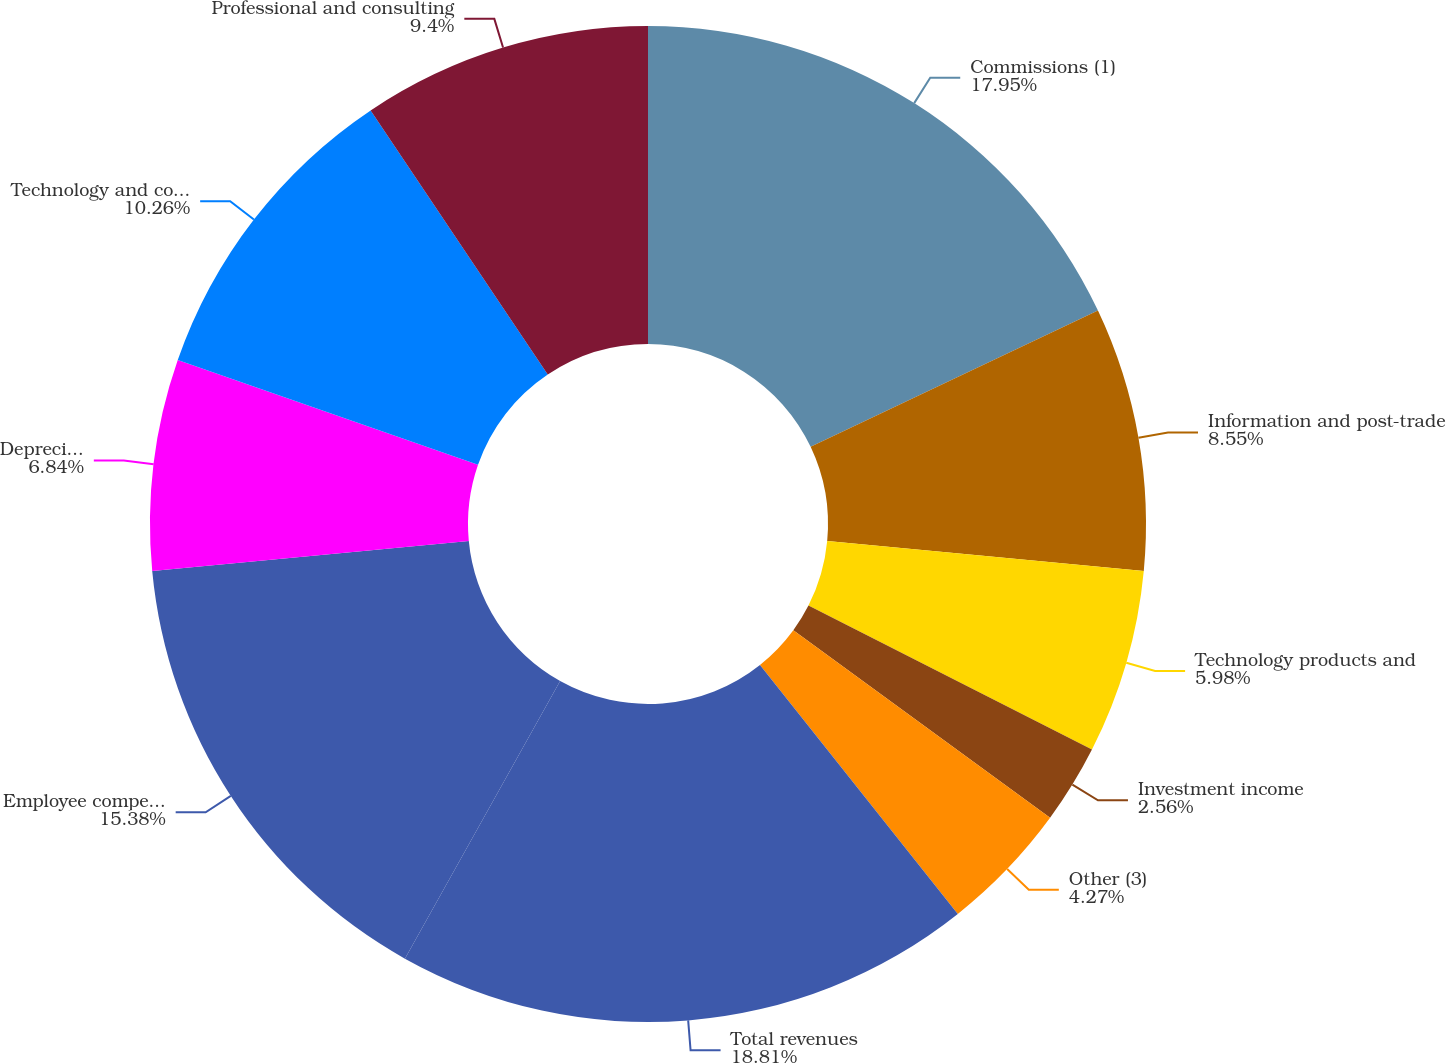<chart> <loc_0><loc_0><loc_500><loc_500><pie_chart><fcel>Commissions (1)<fcel>Information and post-trade<fcel>Technology products and<fcel>Investment income<fcel>Other (3)<fcel>Total revenues<fcel>Employee compensation and<fcel>Depreciation and amortization<fcel>Technology and communications<fcel>Professional and consulting<nl><fcel>17.95%<fcel>8.55%<fcel>5.98%<fcel>2.56%<fcel>4.27%<fcel>18.8%<fcel>15.38%<fcel>6.84%<fcel>10.26%<fcel>9.4%<nl></chart> 